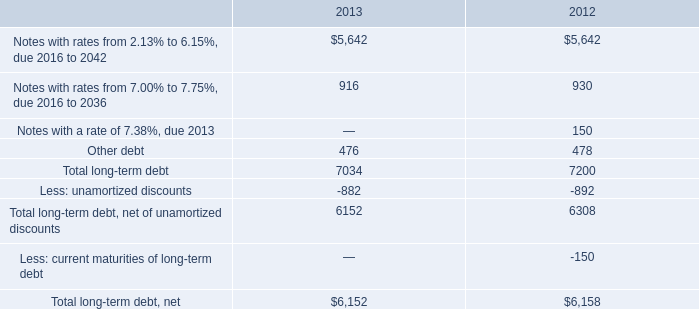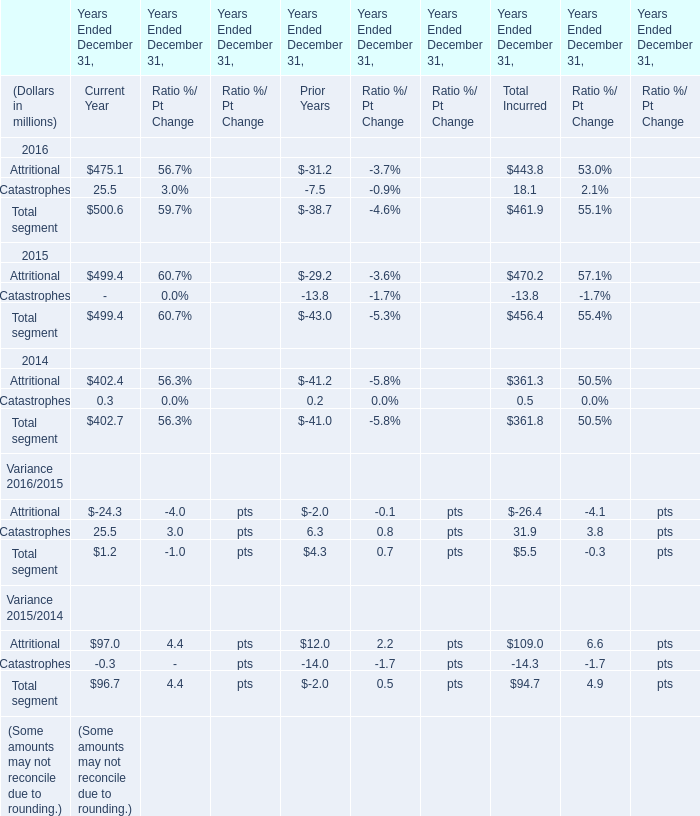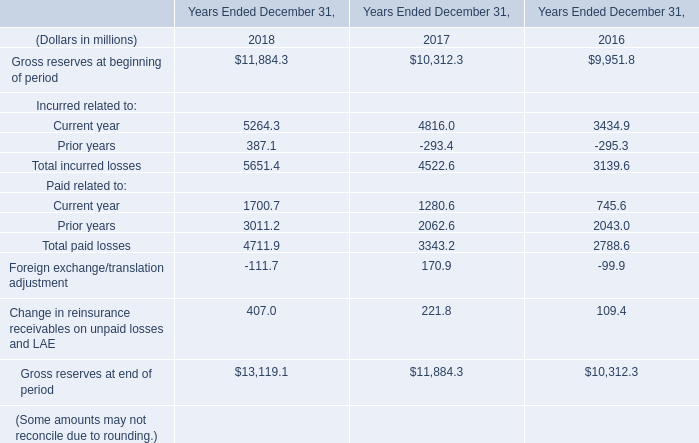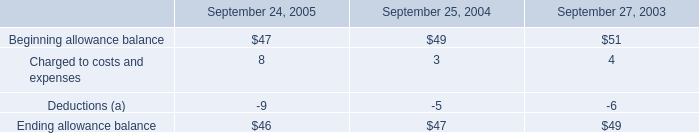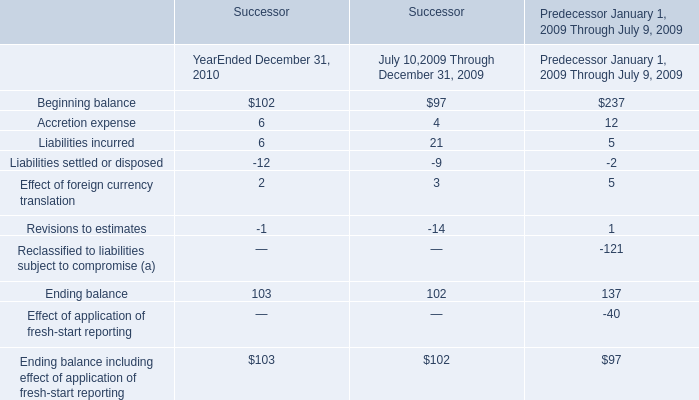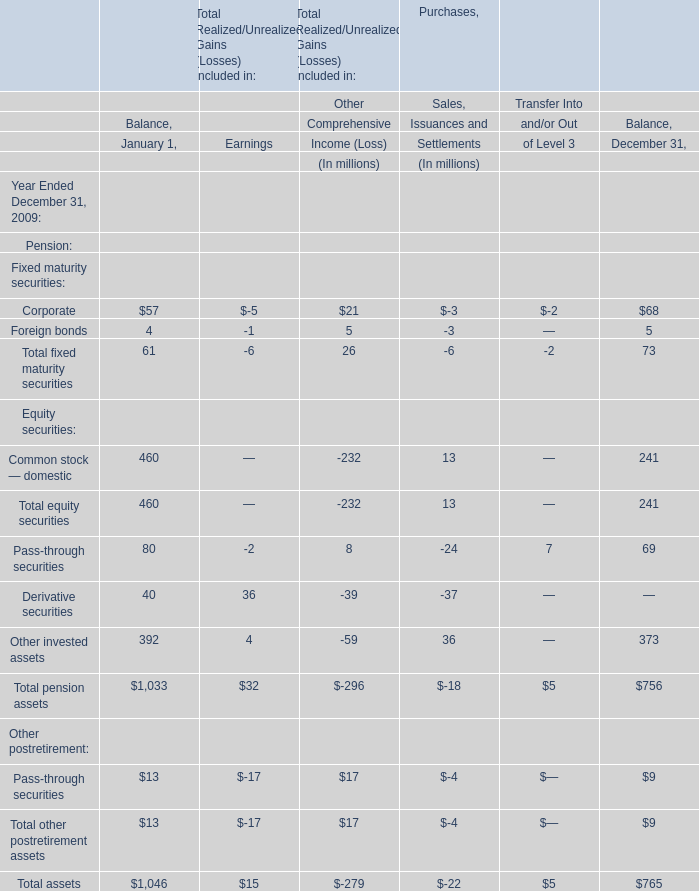In the section with lowest amount of Attritional, what's the increasing rate of Total segment？ 
Computations: ((-38.7 - -43) / -38.7)
Answer: -0.11111. 